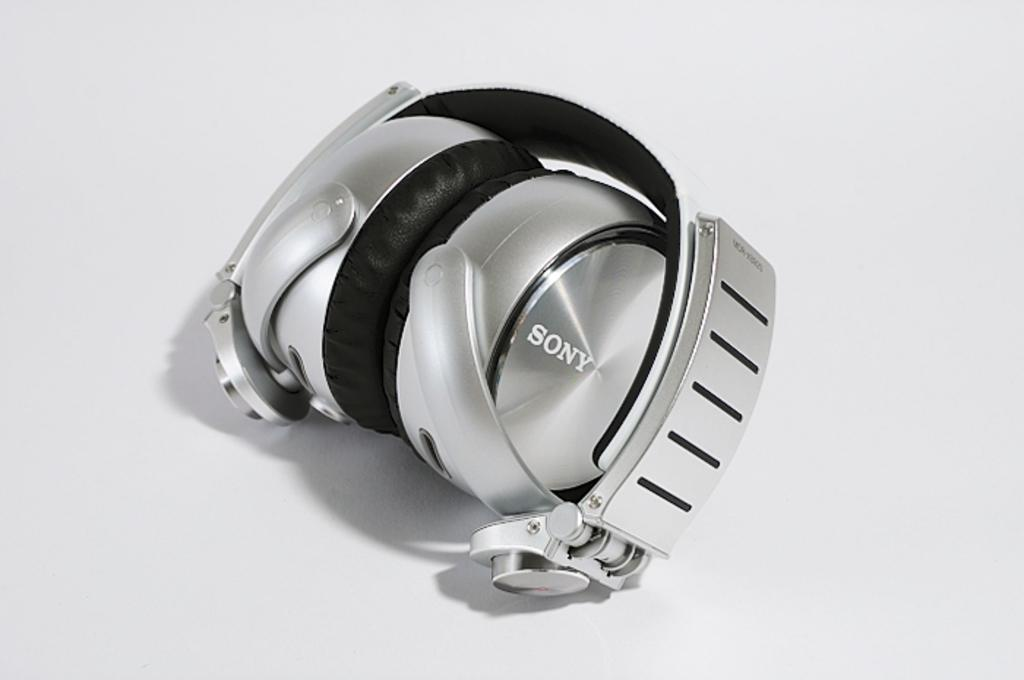<image>
Describe the image concisely. Silver headphones which say SONY on the front. 